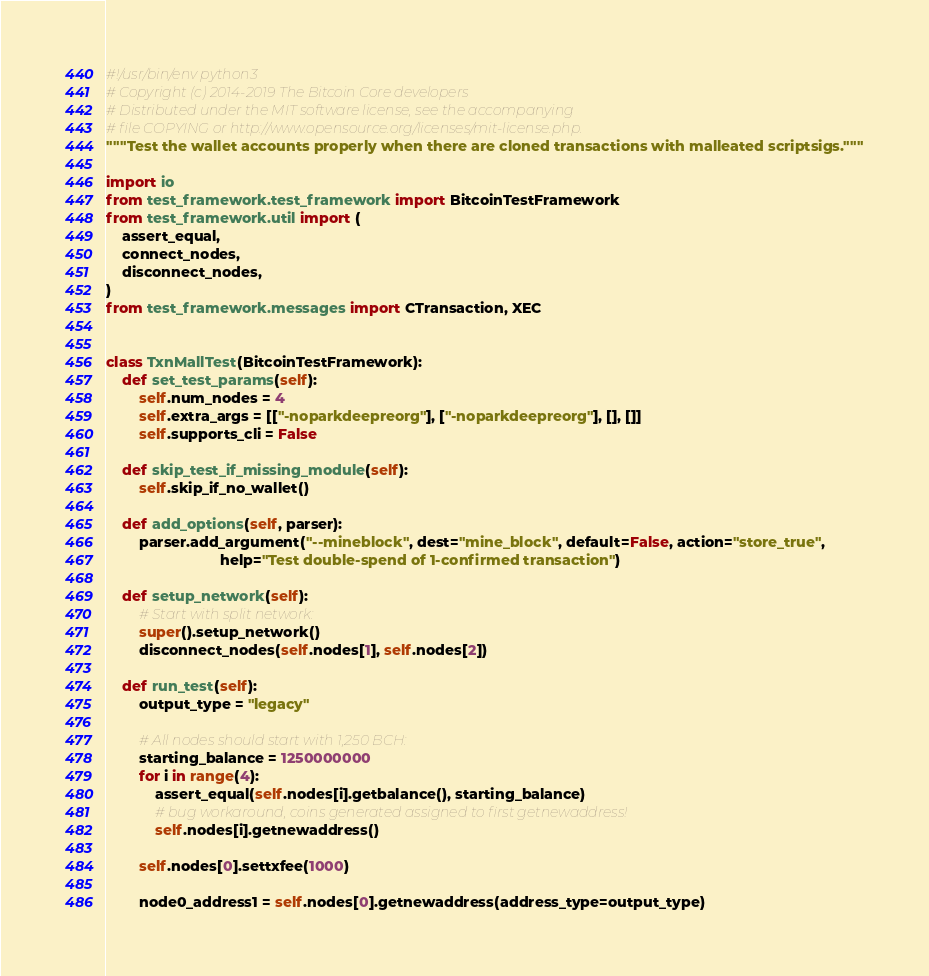<code> <loc_0><loc_0><loc_500><loc_500><_Python_>#!/usr/bin/env python3
# Copyright (c) 2014-2019 The Bitcoin Core developers
# Distributed under the MIT software license, see the accompanying
# file COPYING or http://www.opensource.org/licenses/mit-license.php.
"""Test the wallet accounts properly when there are cloned transactions with malleated scriptsigs."""

import io
from test_framework.test_framework import BitcoinTestFramework
from test_framework.util import (
    assert_equal,
    connect_nodes,
    disconnect_nodes,
)
from test_framework.messages import CTransaction, XEC


class TxnMallTest(BitcoinTestFramework):
    def set_test_params(self):
        self.num_nodes = 4
        self.extra_args = [["-noparkdeepreorg"], ["-noparkdeepreorg"], [], []]
        self.supports_cli = False

    def skip_test_if_missing_module(self):
        self.skip_if_no_wallet()

    def add_options(self, parser):
        parser.add_argument("--mineblock", dest="mine_block", default=False, action="store_true",
                            help="Test double-spend of 1-confirmed transaction")

    def setup_network(self):
        # Start with split network:
        super().setup_network()
        disconnect_nodes(self.nodes[1], self.nodes[2])

    def run_test(self):
        output_type = "legacy"

        # All nodes should start with 1,250 BCH:
        starting_balance = 1250000000
        for i in range(4):
            assert_equal(self.nodes[i].getbalance(), starting_balance)
            # bug workaround, coins generated assigned to first getnewaddress!
            self.nodes[i].getnewaddress()

        self.nodes[0].settxfee(1000)

        node0_address1 = self.nodes[0].getnewaddress(address_type=output_type)</code> 